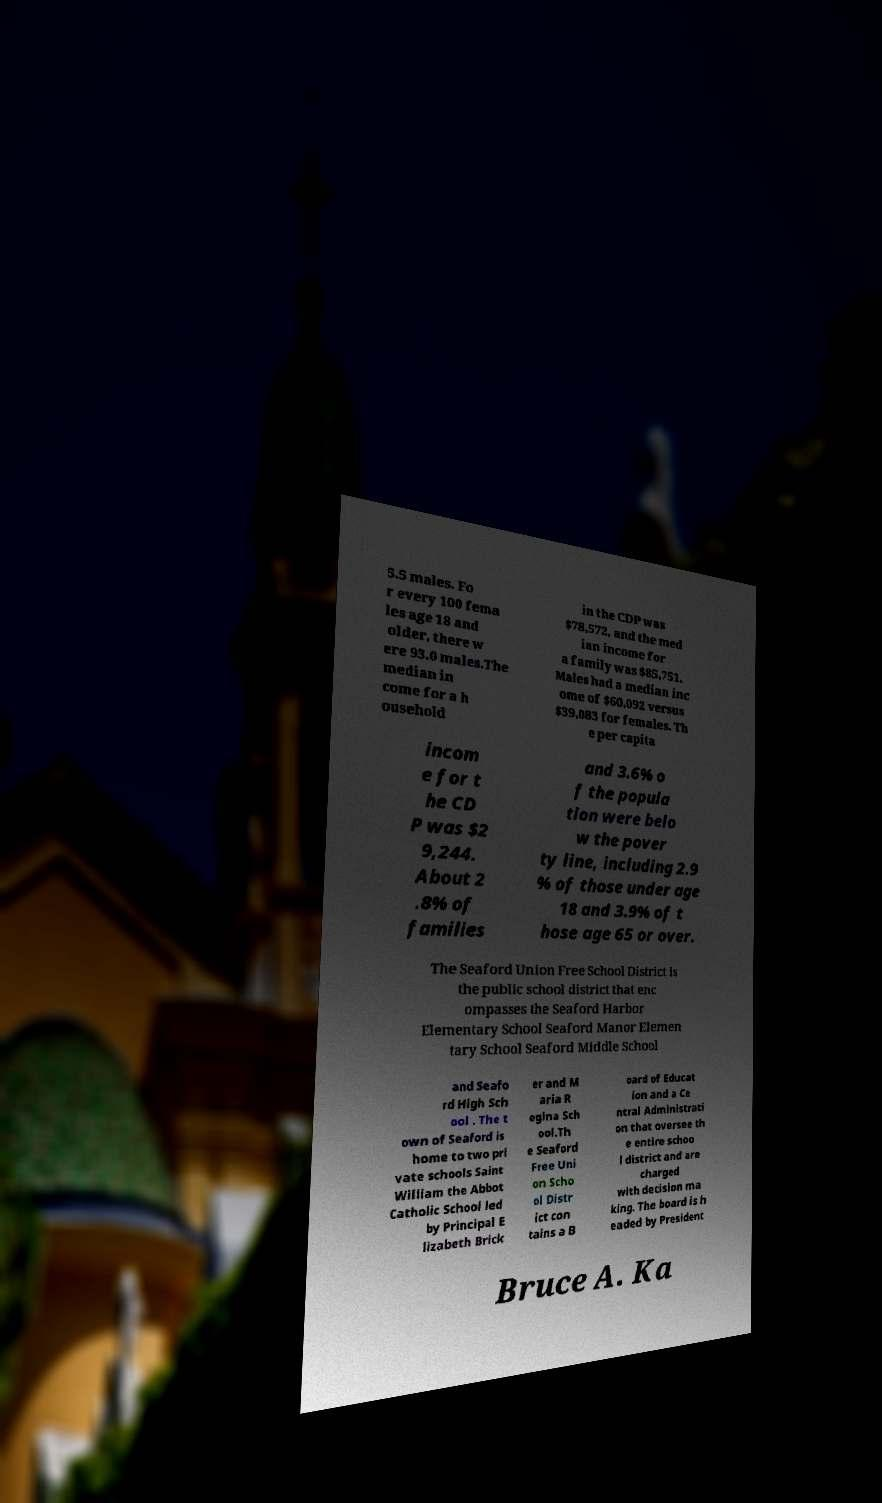For documentation purposes, I need the text within this image transcribed. Could you provide that? 5.5 males. Fo r every 100 fema les age 18 and older, there w ere 93.0 males.The median in come for a h ousehold in the CDP was $78,572, and the med ian income for a family was $85,751. Males had a median inc ome of $60,092 versus $39,083 for females. Th e per capita incom e for t he CD P was $2 9,244. About 2 .8% of families and 3.6% o f the popula tion were belo w the pover ty line, including 2.9 % of those under age 18 and 3.9% of t hose age 65 or over. The Seaford Union Free School District is the public school district that enc ompasses the Seaford Harbor Elementary School Seaford Manor Elemen tary School Seaford Middle School and Seafo rd High Sch ool . The t own of Seaford is home to two pri vate schools Saint William the Abbot Catholic School led by Principal E lizabeth Brick er and M aria R egina Sch ool.Th e Seaford Free Uni on Scho ol Distr ict con tains a B oard of Educat ion and a Ce ntral Administrati on that oversee th e entire schoo l district and are charged with decision ma king. The board is h eaded by President Bruce A. Ka 